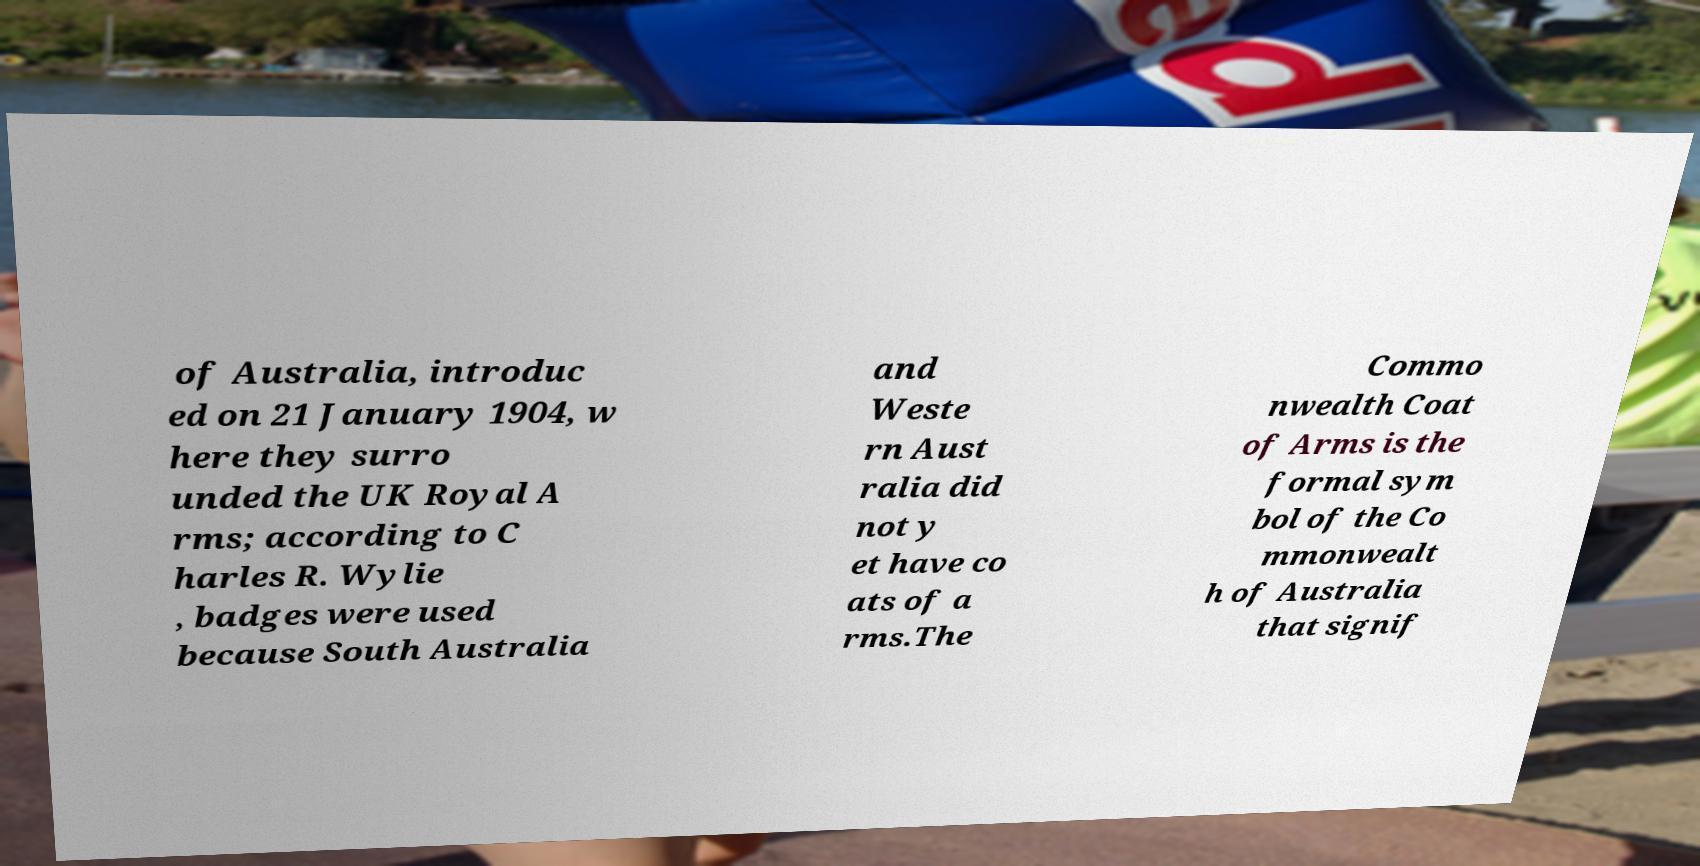Can you read and provide the text displayed in the image?This photo seems to have some interesting text. Can you extract and type it out for me? of Australia, introduc ed on 21 January 1904, w here they surro unded the UK Royal A rms; according to C harles R. Wylie , badges were used because South Australia and Weste rn Aust ralia did not y et have co ats of a rms.The Commo nwealth Coat of Arms is the formal sym bol of the Co mmonwealt h of Australia that signif 